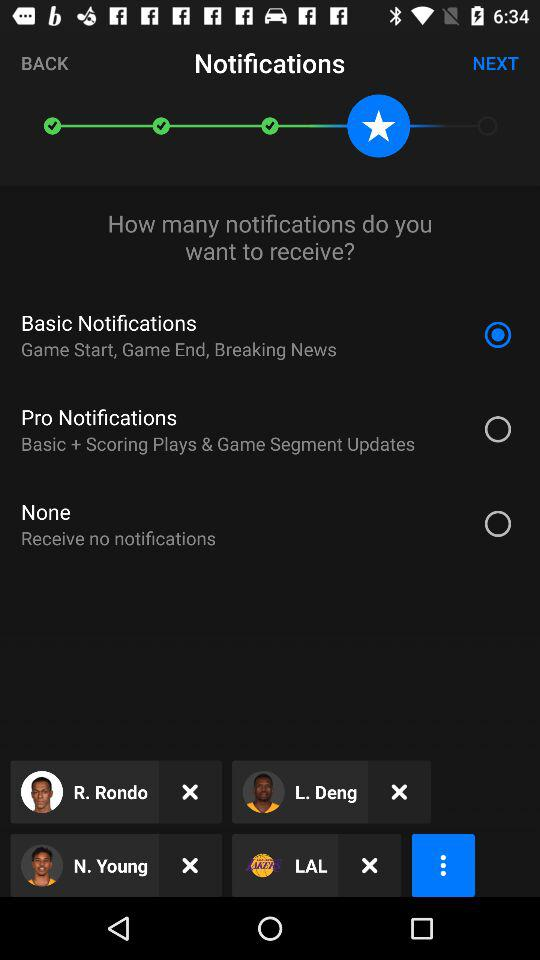What is the description of "None"? The description is "Receive no notifications". 